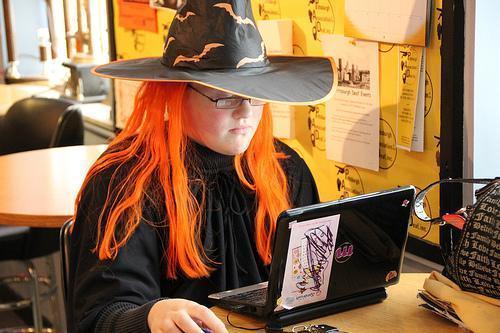How many witches are shown?
Give a very brief answer. 1. 